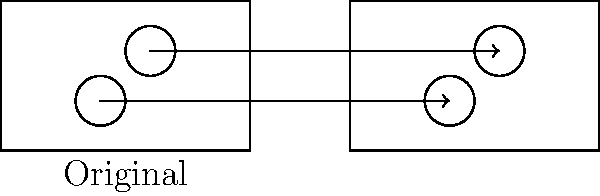The restaurant owner wants to create a new seating arrangement by moving two circular tables. If table E is translated 7 units to the right and table F is translated by the same vector, what are the coordinates of table F in the new arrangement? Let's approach this step-by-step:

1) First, we need to identify the original coordinates of table F.
   From the diagram, we can see that F is at (3*unit, 2*unit).
   If we assume 1 unit = 20, then F is at (60, 40).

2) The translation vector is 7 units to the right, which means:
   Translation vector = (7*20, 0) = (140, 0)

3) To find the new position of F, we add the translation vector to its original coordinates:
   New F = Original F + Translation vector
   New F = (60, 40) + (140, 0)
   New F = (60+140, 40+0) = (200, 40)

4) Therefore, in the new arrangement, table F will be at coordinates (200, 40).
Answer: (200, 40) 